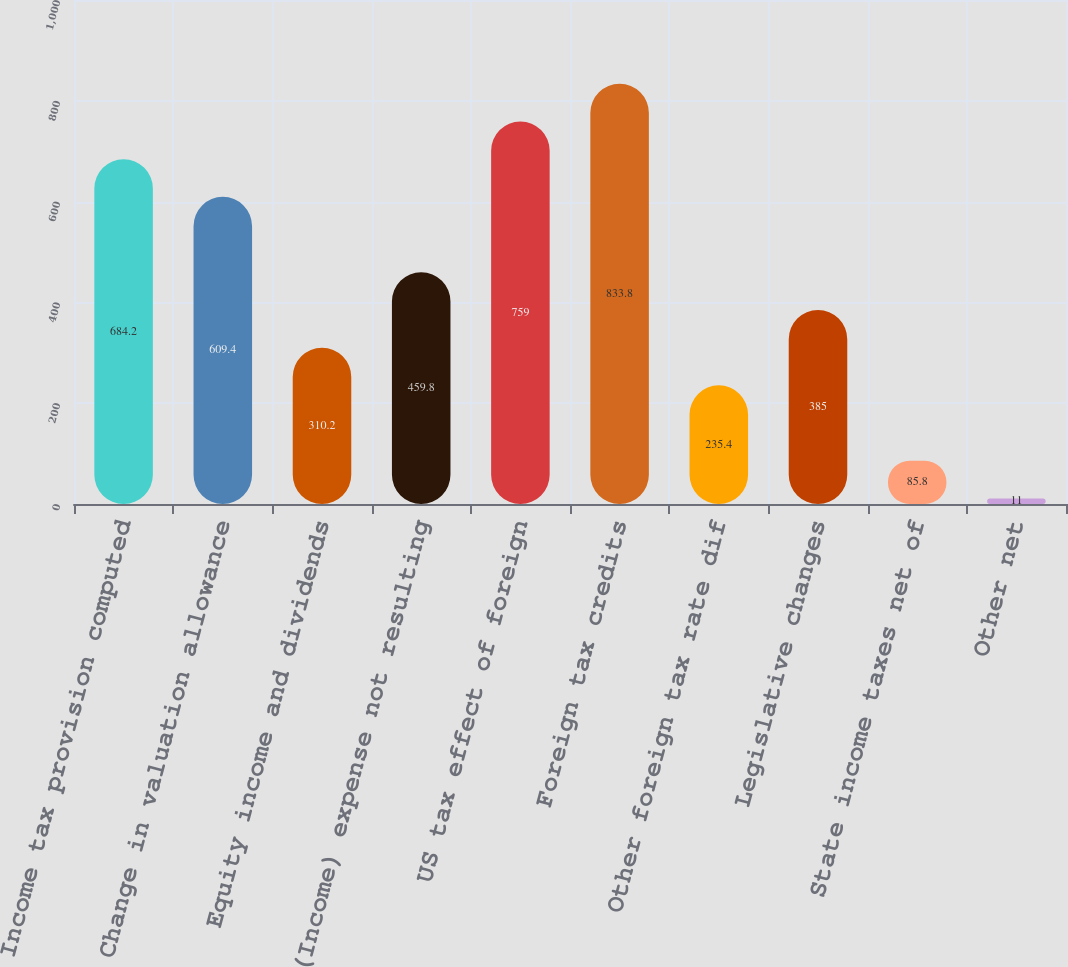<chart> <loc_0><loc_0><loc_500><loc_500><bar_chart><fcel>Income tax provision computed<fcel>Change in valuation allowance<fcel>Equity income and dividends<fcel>(Income) expense not resulting<fcel>US tax effect of foreign<fcel>Foreign tax credits<fcel>Other foreign tax rate dif<fcel>Legislative changes<fcel>State income taxes net of<fcel>Other net<nl><fcel>684.2<fcel>609.4<fcel>310.2<fcel>459.8<fcel>759<fcel>833.8<fcel>235.4<fcel>385<fcel>85.8<fcel>11<nl></chart> 